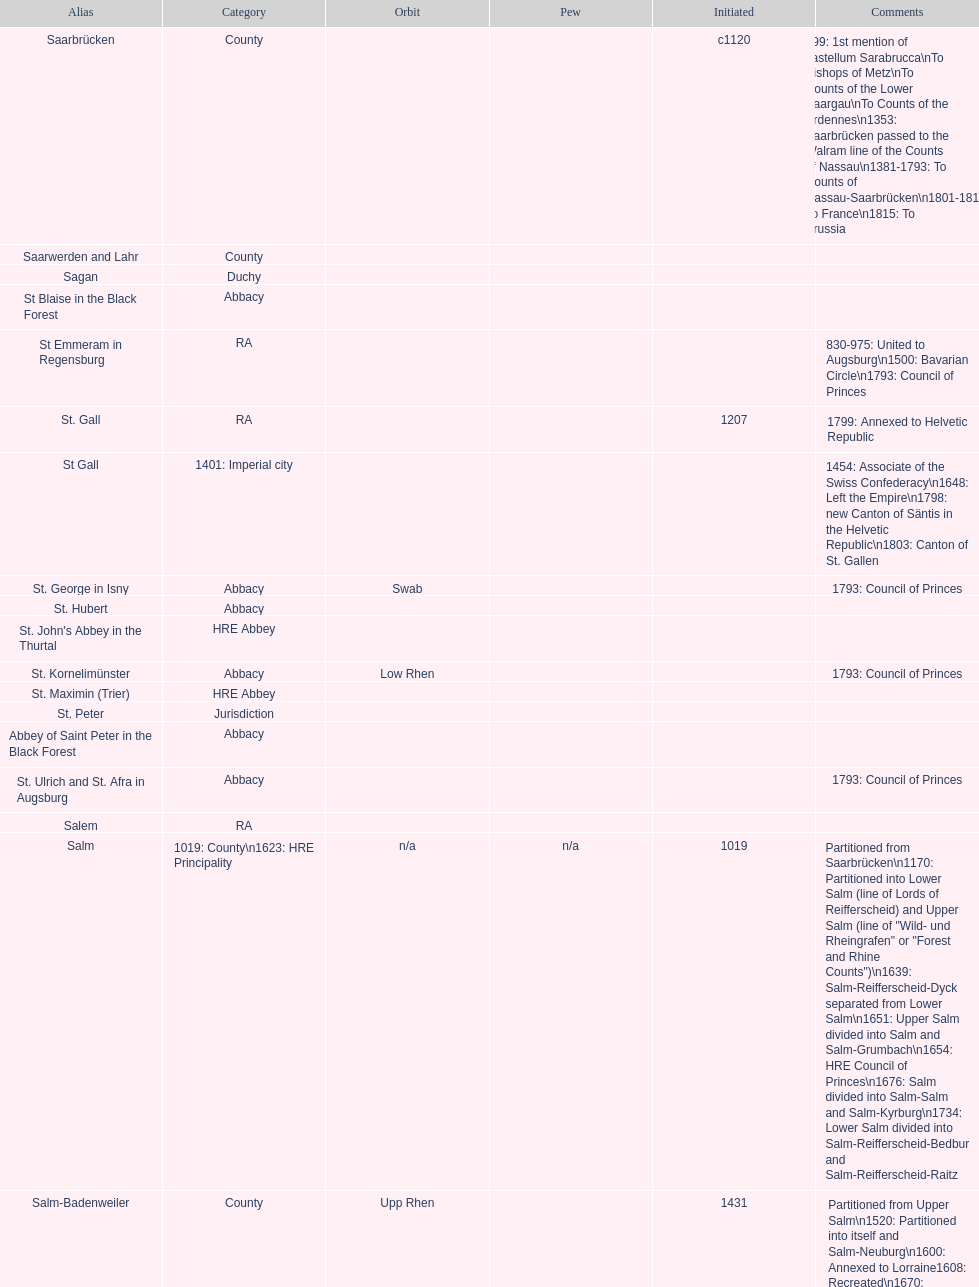How many states were of the same type as stuhlingen? 3. 